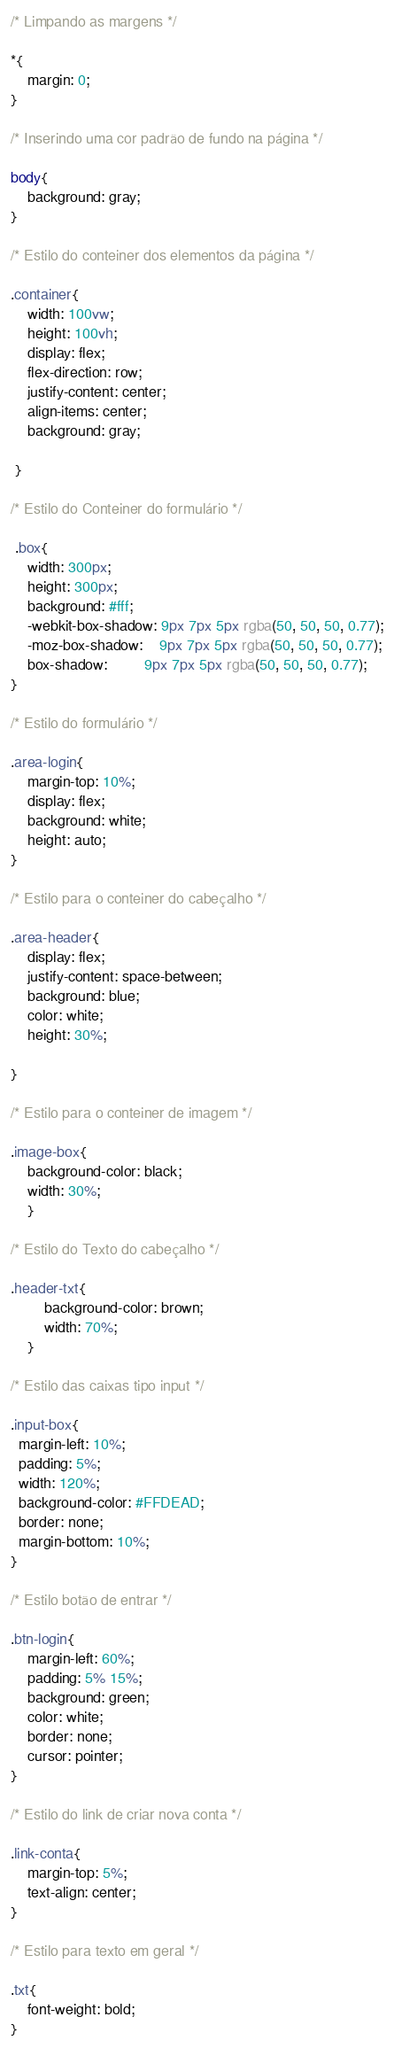Convert code to text. <code><loc_0><loc_0><loc_500><loc_500><_CSS_>
/* Limpando as margens */

*{
    margin: 0;
}

/* Inserindo uma cor padrão de fundo na página */

body{
    background: gray; 
}

/* Estilo do conteiner dos elementos da página */

.container{ 
    width: 100vw;
    height: 100vh;
    display: flex;
    flex-direction: row;
    justify-content: center;
    align-items: center;
    background: gray;
    
 }

/* Estilo do Conteiner do formulário */

 .box{
    width: 300px;
    height: 300px;
    background: #fff;
    -webkit-box-shadow: 9px 7px 5px rgba(50, 50, 50, 0.77);
	-moz-box-shadow:    9px 7px 5px rgba(50, 50, 50, 0.77);
	box-shadow:         9px 7px 5px rgba(50, 50, 50, 0.77);
}

/* Estilo do formulário */

.area-login{
    margin-top: 10%;
    display: flex;
    background: white;
    height: auto;    
}

/* Estilo para o conteiner do cabeçalho */

.area-header{
    display: flex;
    justify-content: space-between;
    background: blue;
    color: white;
    height: 30%;

}

/* Estilo para o conteiner de imagem */

.image-box{
    background-color: black;
    width: 30%; 
    }
    
/* Estilo do Texto do cabeçalho */

.header-txt{
        background-color: brown;
        width: 70%;
    }

/* Estilo das caixas tipo input */

.input-box{ 
  margin-left: 10%;  
  padding: 5%;
  width: 120%; 
  background-color: #FFDEAD;
  border: none;
  margin-bottom: 10%;
}

/* Estilo botão de entrar */

.btn-login{
    margin-left: 60%;
    padding: 5% 15%;
    background: green;
    color: white;
    border: none;
    cursor: pointer;
}

/* Estilo do link de criar nova conta */

.link-conta{
    margin-top: 5%;
    text-align: center;
}

/* Estilo para texto em geral */

.txt{
    font-weight: bold;
}

</code> 